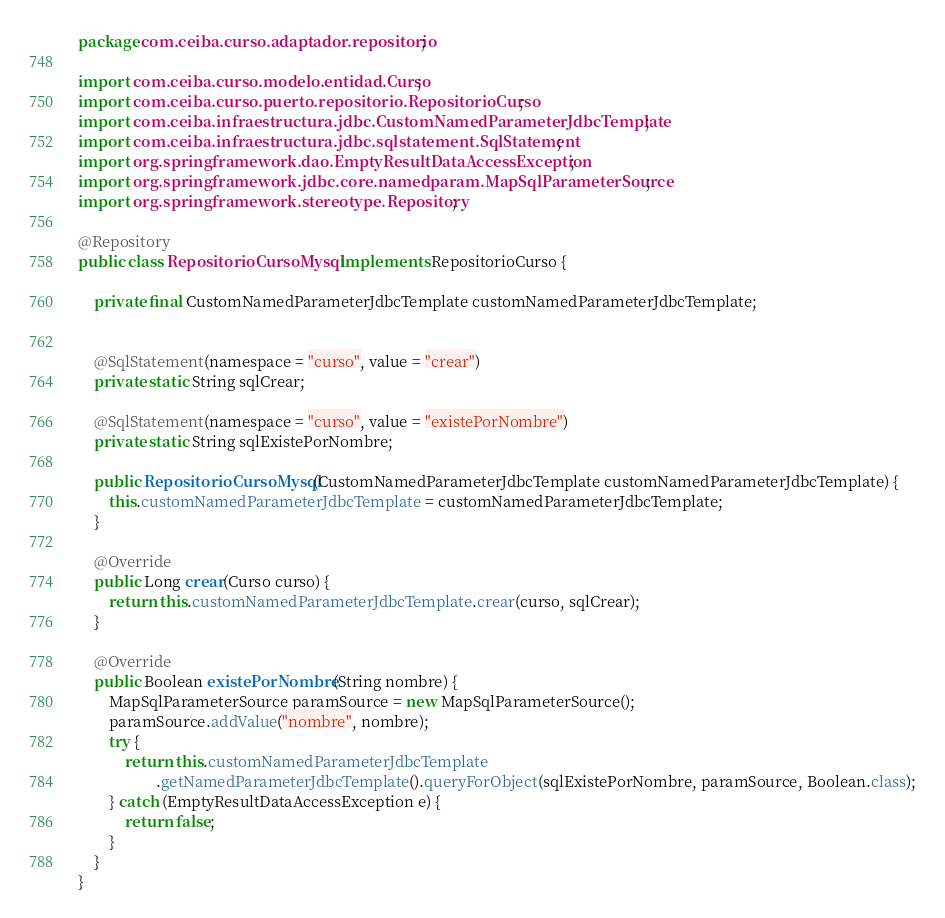Convert code to text. <code><loc_0><loc_0><loc_500><loc_500><_Java_>package com.ceiba.curso.adaptador.repositorio;

import com.ceiba.curso.modelo.entidad.Curso;
import com.ceiba.curso.puerto.repositorio.RepositorioCurso;
import com.ceiba.infraestructura.jdbc.CustomNamedParameterJdbcTemplate;
import com.ceiba.infraestructura.jdbc.sqlstatement.SqlStatement;
import org.springframework.dao.EmptyResultDataAccessException;
import org.springframework.jdbc.core.namedparam.MapSqlParameterSource;
import org.springframework.stereotype.Repository;

@Repository
public class RepositorioCursoMysql implements RepositorioCurso {

    private final CustomNamedParameterJdbcTemplate customNamedParameterJdbcTemplate;


    @SqlStatement(namespace = "curso", value = "crear")
    private static String sqlCrear;

    @SqlStatement(namespace = "curso", value = "existePorNombre")
    private static String sqlExistePorNombre;

    public RepositorioCursoMysql(CustomNamedParameterJdbcTemplate customNamedParameterJdbcTemplate) {
        this.customNamedParameterJdbcTemplate = customNamedParameterJdbcTemplate;
    }

    @Override
    public Long crear(Curso curso) {
        return this.customNamedParameterJdbcTemplate.crear(curso, sqlCrear);
    }

    @Override
    public Boolean existePorNombre(String nombre) {
        MapSqlParameterSource paramSource = new MapSqlParameterSource();
        paramSource.addValue("nombre", nombre);
        try {
            return this.customNamedParameterJdbcTemplate
                    .getNamedParameterJdbcTemplate().queryForObject(sqlExistePorNombre, paramSource, Boolean.class);
        } catch (EmptyResultDataAccessException e) {
            return false;
        }
    }
}














</code> 